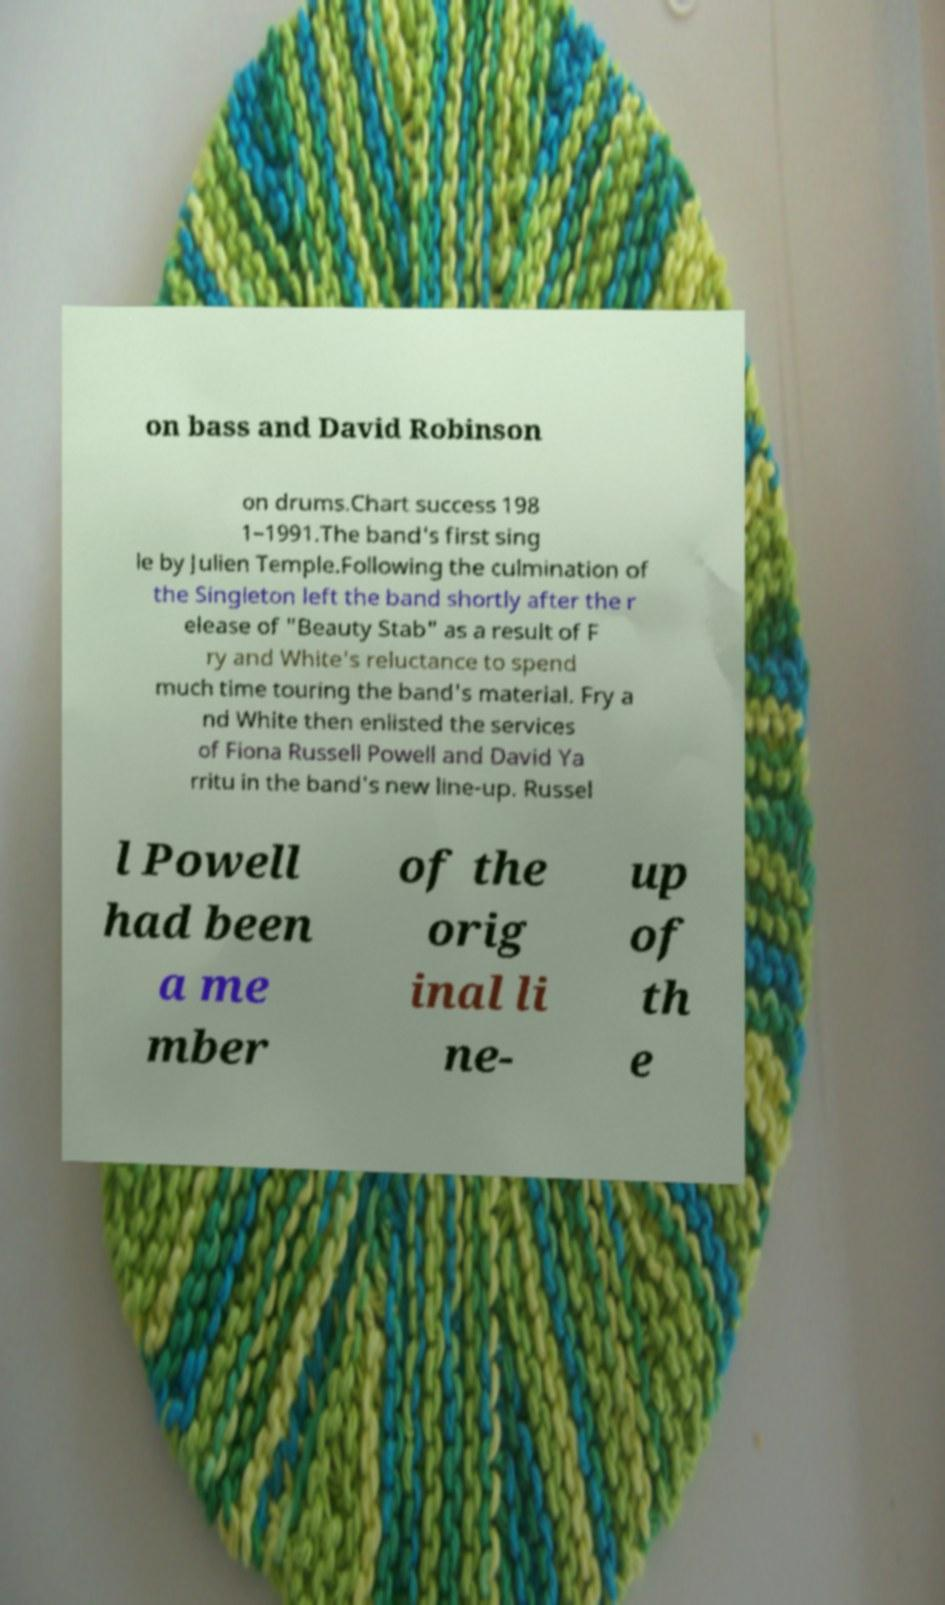Please read and relay the text visible in this image. What does it say? on bass and David Robinson on drums.Chart success 198 1–1991.The band's first sing le by Julien Temple.Following the culmination of the Singleton left the band shortly after the r elease of "Beauty Stab" as a result of F ry and White's reluctance to spend much time touring the band's material. Fry a nd White then enlisted the services of Fiona Russell Powell and David Ya rritu in the band's new line-up. Russel l Powell had been a me mber of the orig inal li ne- up of th e 